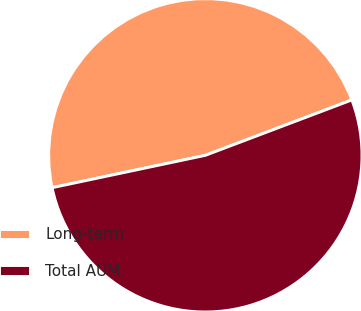Convert chart to OTSL. <chart><loc_0><loc_0><loc_500><loc_500><pie_chart><fcel>Long-term<fcel>Total AUM<nl><fcel>47.56%<fcel>52.44%<nl></chart> 